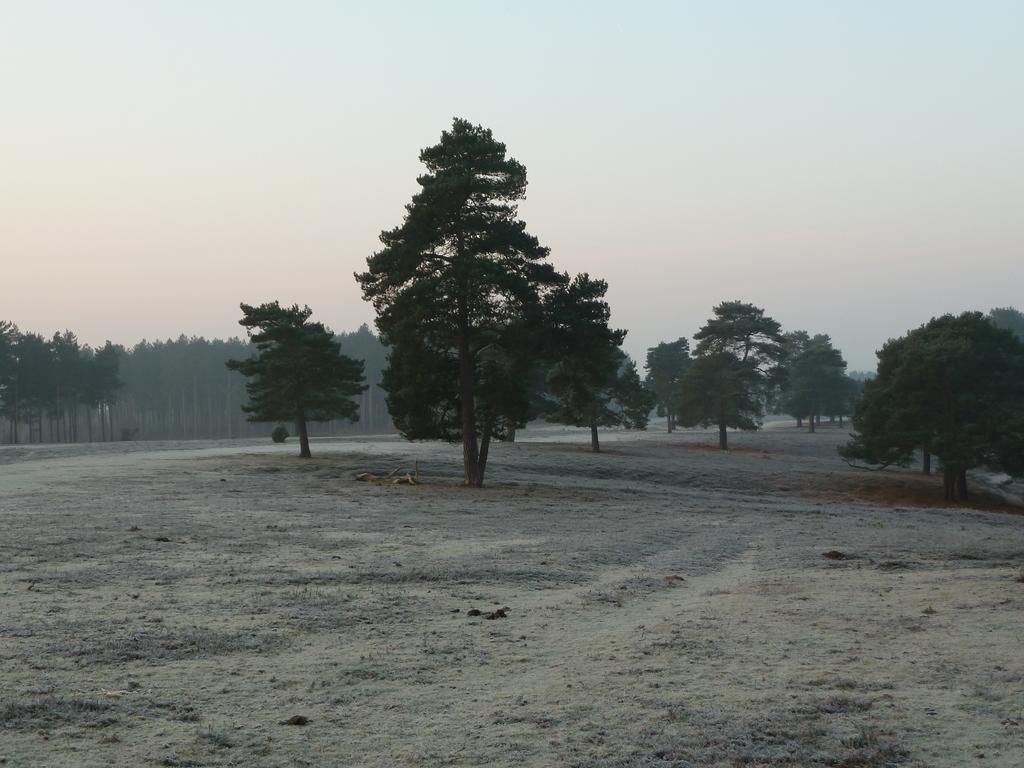What is the color scheme of the image? The image is black and white. What can be seen in the background of the image? There are trees in the background of the image. What is visible in the image besides the trees? The sky is visible in the image. What type of flesh can be seen in the image? There is no flesh present in the image, as it is a black and white image with trees and sky visible. 